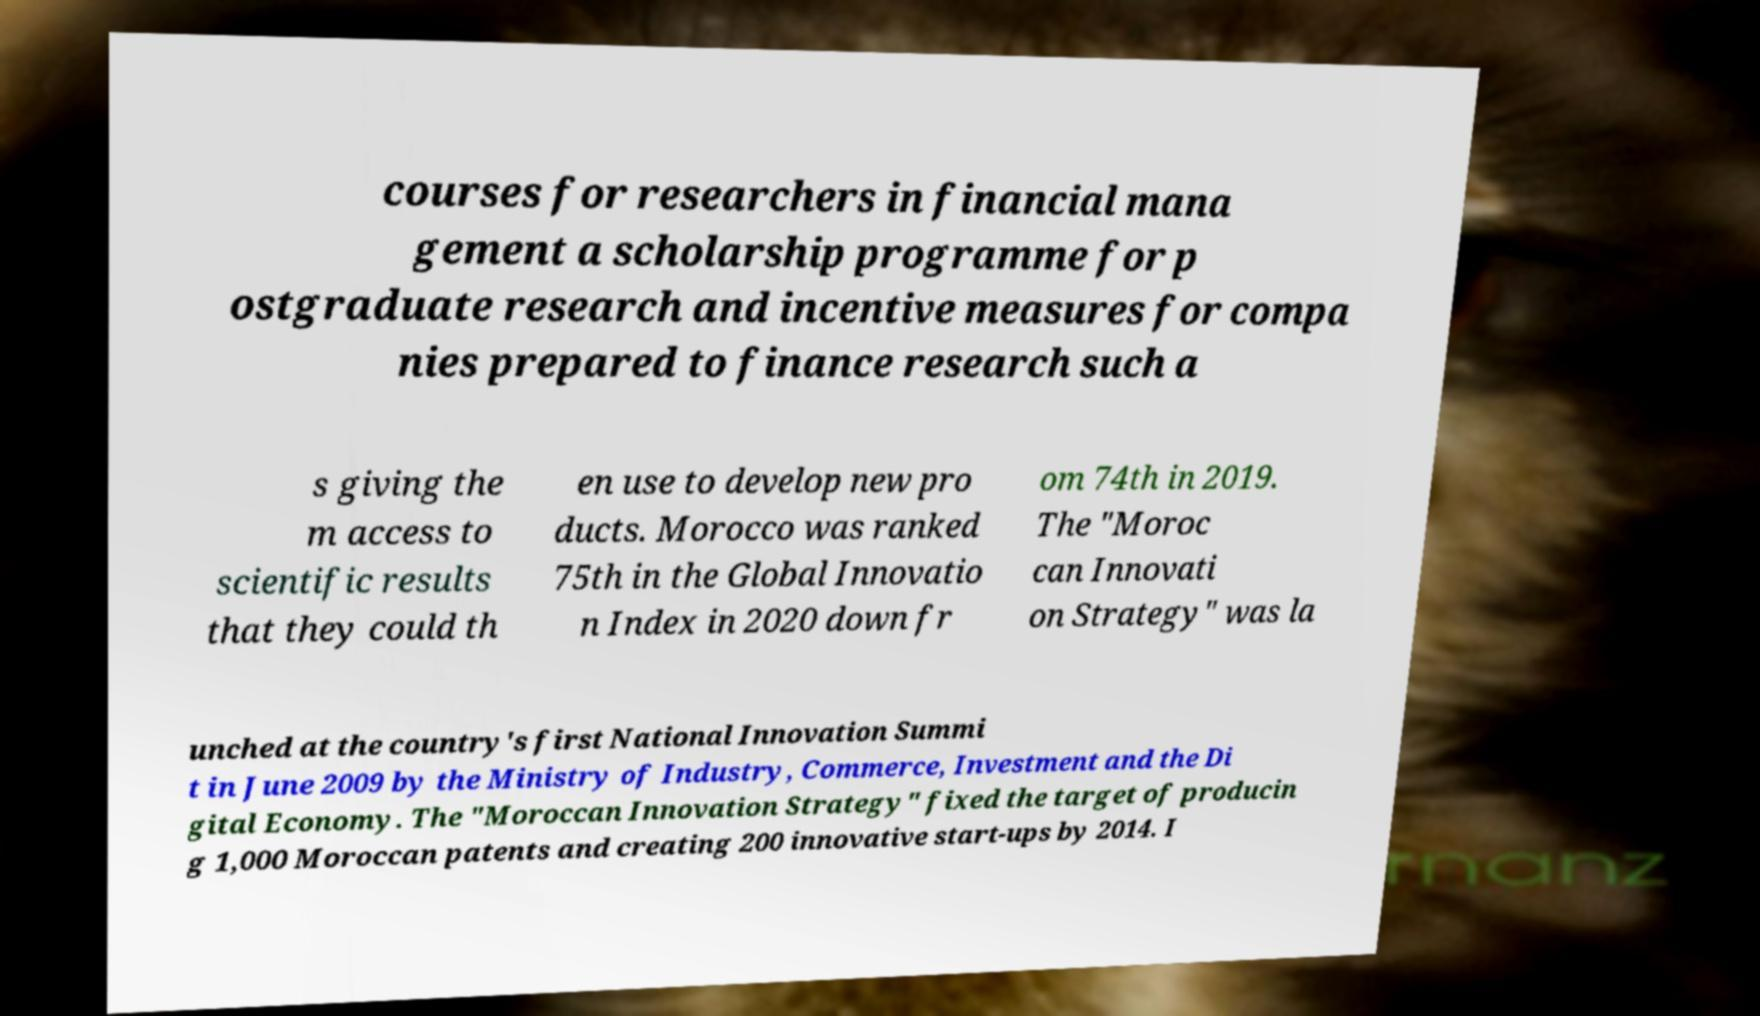What messages or text are displayed in this image? I need them in a readable, typed format. courses for researchers in financial mana gement a scholarship programme for p ostgraduate research and incentive measures for compa nies prepared to finance research such a s giving the m access to scientific results that they could th en use to develop new pro ducts. Morocco was ranked 75th in the Global Innovatio n Index in 2020 down fr om 74th in 2019. The "Moroc can Innovati on Strategy" was la unched at the country's first National Innovation Summi t in June 2009 by the Ministry of Industry, Commerce, Investment and the Di gital Economy. The "Moroccan Innovation Strategy" fixed the target of producin g 1,000 Moroccan patents and creating 200 innovative start-ups by 2014. I 